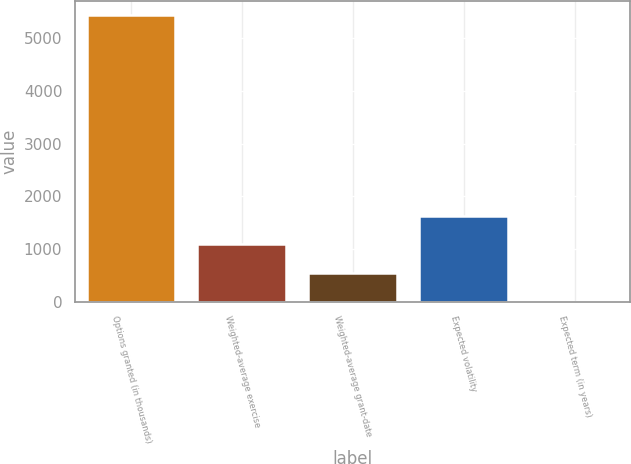Convert chart to OTSL. <chart><loc_0><loc_0><loc_500><loc_500><bar_chart><fcel>Options granted (in thousands)<fcel>Weighted-average exercise<fcel>Weighted-average grant-date<fcel>Expected volatility<fcel>Expected term (in years)<nl><fcel>5438<fcel>1091.6<fcel>548.3<fcel>1634.9<fcel>5<nl></chart> 